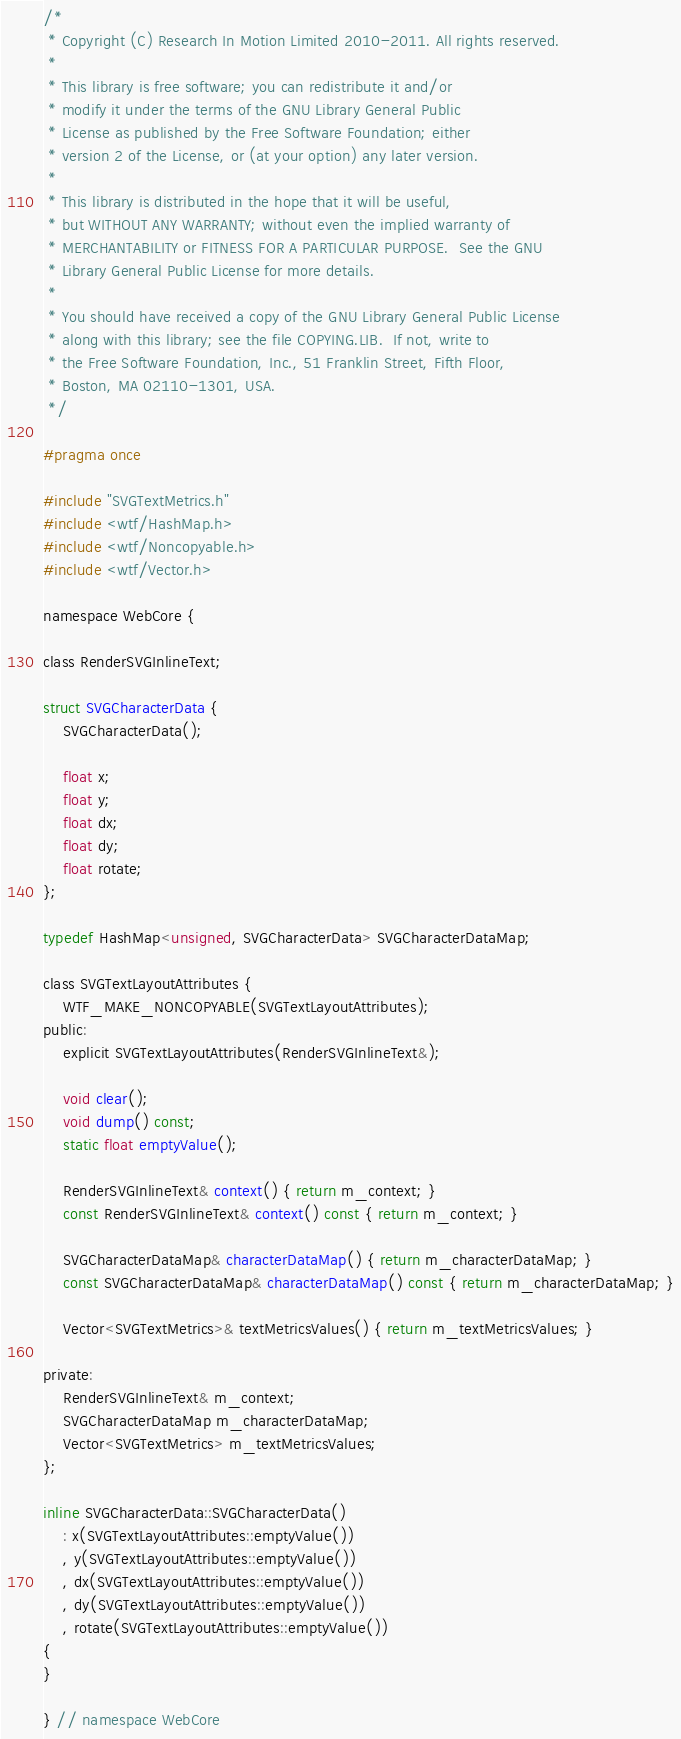Convert code to text. <code><loc_0><loc_0><loc_500><loc_500><_C_>/*
 * Copyright (C) Research In Motion Limited 2010-2011. All rights reserved.
 *
 * This library is free software; you can redistribute it and/or
 * modify it under the terms of the GNU Library General Public
 * License as published by the Free Software Foundation; either
 * version 2 of the License, or (at your option) any later version.
 *
 * This library is distributed in the hope that it will be useful,
 * but WITHOUT ANY WARRANTY; without even the implied warranty of
 * MERCHANTABILITY or FITNESS FOR A PARTICULAR PURPOSE.  See the GNU
 * Library General Public License for more details.
 *
 * You should have received a copy of the GNU Library General Public License
 * along with this library; see the file COPYING.LIB.  If not, write to
 * the Free Software Foundation, Inc., 51 Franklin Street, Fifth Floor,
 * Boston, MA 02110-1301, USA.
 */

#pragma once

#include "SVGTextMetrics.h"
#include <wtf/HashMap.h>
#include <wtf/Noncopyable.h>
#include <wtf/Vector.h>

namespace WebCore {

class RenderSVGInlineText;

struct SVGCharacterData {
    SVGCharacterData();

    float x;
    float y;
    float dx;
    float dy;
    float rotate;
};

typedef HashMap<unsigned, SVGCharacterData> SVGCharacterDataMap;

class SVGTextLayoutAttributes {
    WTF_MAKE_NONCOPYABLE(SVGTextLayoutAttributes);
public:
    explicit SVGTextLayoutAttributes(RenderSVGInlineText&);

    void clear();
    void dump() const;
    static float emptyValue();

    RenderSVGInlineText& context() { return m_context; }
    const RenderSVGInlineText& context() const { return m_context; }
    
    SVGCharacterDataMap& characterDataMap() { return m_characterDataMap; }
    const SVGCharacterDataMap& characterDataMap() const { return m_characterDataMap; }

    Vector<SVGTextMetrics>& textMetricsValues() { return m_textMetricsValues; }

private:
    RenderSVGInlineText& m_context;
    SVGCharacterDataMap m_characterDataMap;
    Vector<SVGTextMetrics> m_textMetricsValues;
};

inline SVGCharacterData::SVGCharacterData()
    : x(SVGTextLayoutAttributes::emptyValue())
    , y(SVGTextLayoutAttributes::emptyValue())
    , dx(SVGTextLayoutAttributes::emptyValue())
    , dy(SVGTextLayoutAttributes::emptyValue())
    , rotate(SVGTextLayoutAttributes::emptyValue())
{
}

} // namespace WebCore
</code> 